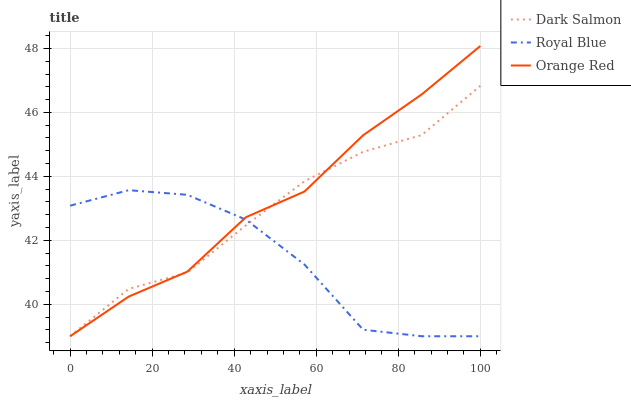Does Royal Blue have the minimum area under the curve?
Answer yes or no. Yes. Does Orange Red have the maximum area under the curve?
Answer yes or no. Yes. Does Dark Salmon have the minimum area under the curve?
Answer yes or no. No. Does Dark Salmon have the maximum area under the curve?
Answer yes or no. No. Is Dark Salmon the smoothest?
Answer yes or no. Yes. Is Royal Blue the roughest?
Answer yes or no. Yes. Is Orange Red the smoothest?
Answer yes or no. No. Is Orange Red the roughest?
Answer yes or no. No. Does Orange Red have the highest value?
Answer yes or no. Yes. Does Dark Salmon have the highest value?
Answer yes or no. No. 